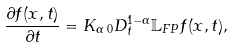Convert formula to latex. <formula><loc_0><loc_0><loc_500><loc_500>\frac { \partial f ( x , t ) } { \partial t } = K _ { \alpha } \, _ { 0 } D _ { t } ^ { 1 - \alpha } \mathbb { L } _ { F P } f ( x , t ) ,</formula> 